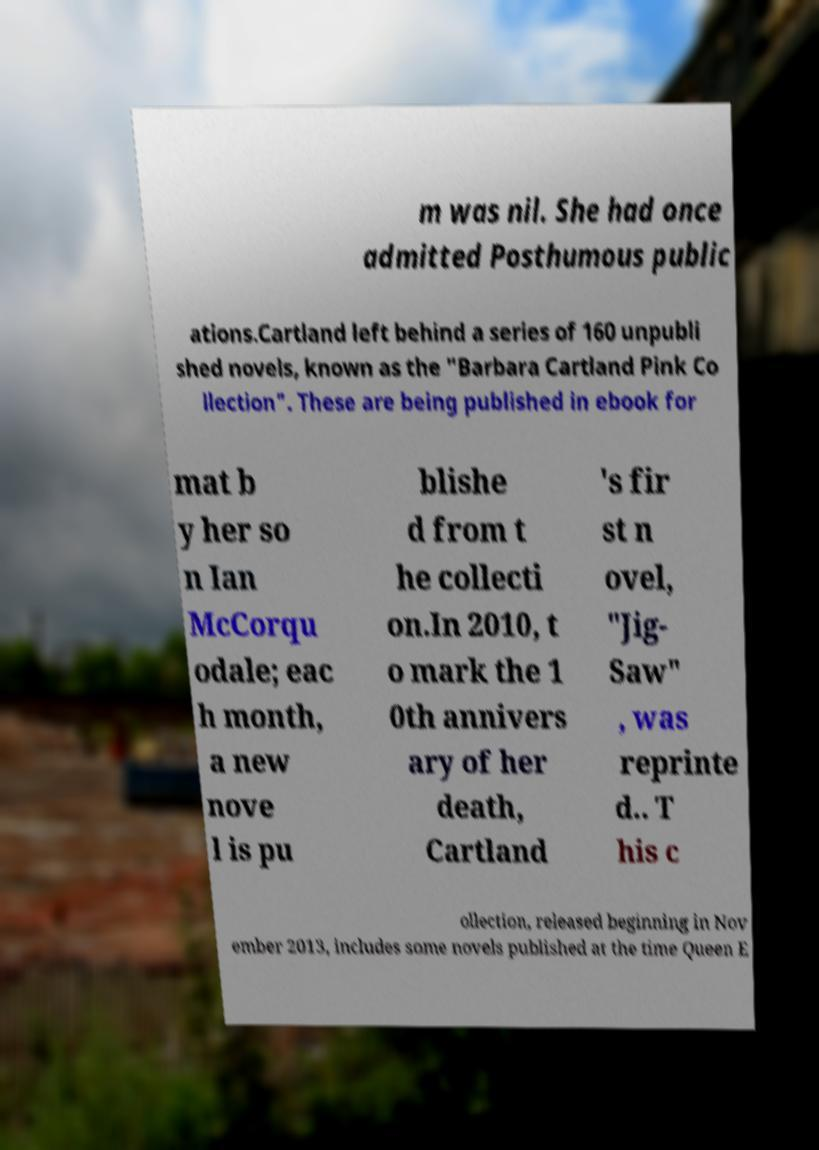Could you extract and type out the text from this image? m was nil. She had once admitted Posthumous public ations.Cartland left behind a series of 160 unpubli shed novels, known as the "Barbara Cartland Pink Co llection". These are being published in ebook for mat b y her so n Ian McCorqu odale; eac h month, a new nove l is pu blishe d from t he collecti on.In 2010, t o mark the 1 0th annivers ary of her death, Cartland 's fir st n ovel, "Jig- Saw" , was reprinte d.. T his c ollection, released beginning in Nov ember 2013, includes some novels published at the time Queen E 